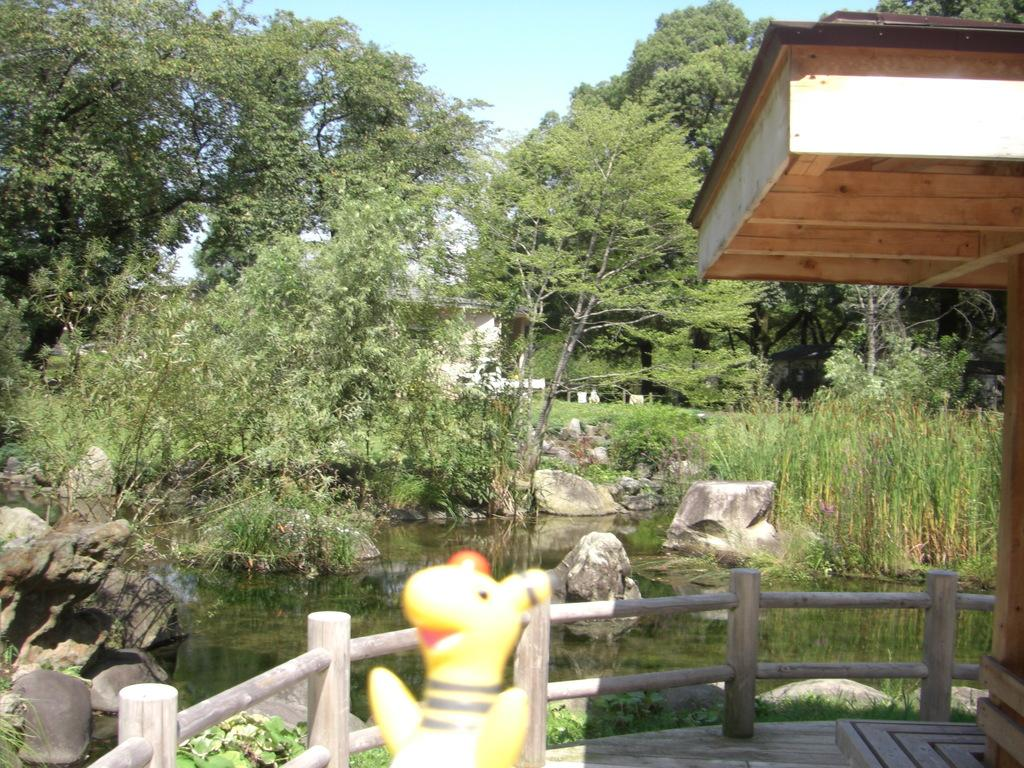What is one of the natural elements present in the image? There is water in the picture. What type of vegetation can be seen in the image? There is grass in the picture. What type of material is used for the fence in the image? There is a wooden fence in the picture. What can be found on the ground in the image? There are rocks in the picture. What is visible in the background of the image? The sky is visible in the background of the picture. Can you describe any other objects present in the image? There are other objects in the picture, but their specific details are not mentioned in the provided facts. What letters are visible on the rocks in the image? There are no letters visible on the rocks in the image. What angle is the wooden fence leaning at in the image? The angle at which the wooden fence is leaning is not mentioned in the provided facts, so it cannot be determined from the image. 